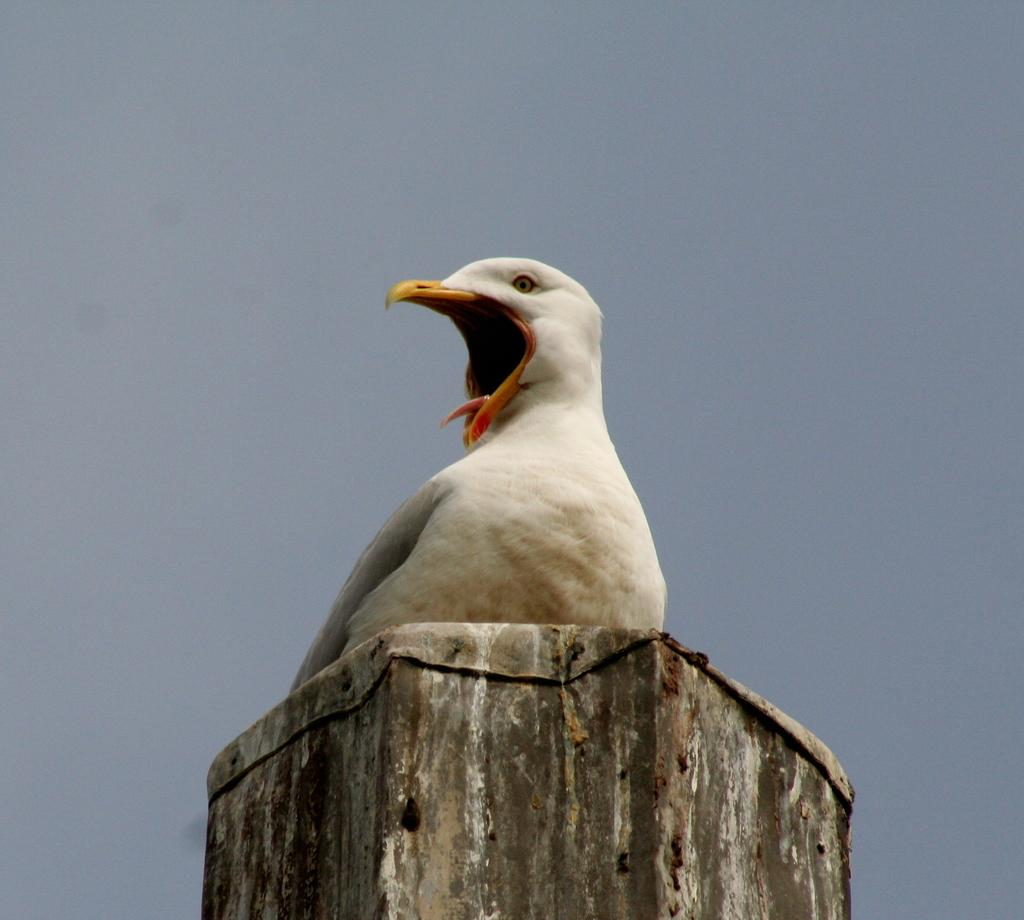What type of animal is in the foreground of the image? There is a white bird in the foreground of the image. Where is the bird located? The bird is on a wooden pole. What can be seen in the background of the image? The sky is visible in the background of the image. What type of liquid is being played on the guitar in the image? There is no guitar present in the image, and therefore no liquid being played on it. 